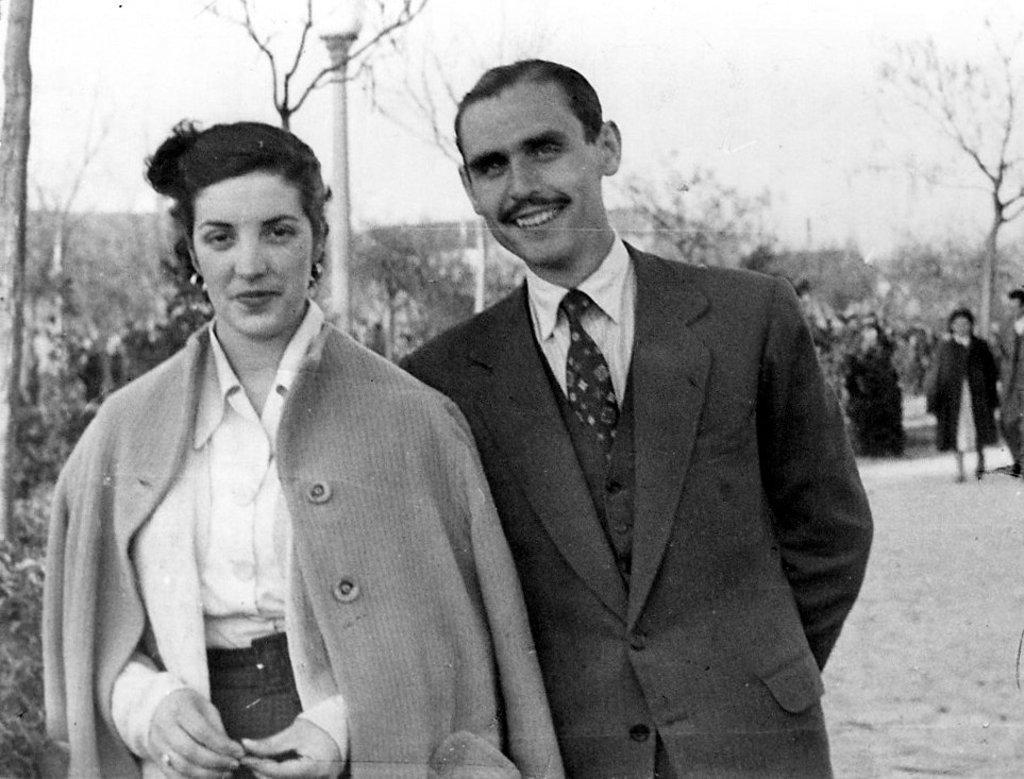Please provide a concise description of this image. As we can see in the image there are few people here and there, trees, street lamp and in the background there are houses. At the top there is a sky. The man over here is wearing black color jacket and the woman is wearing white color dress. 